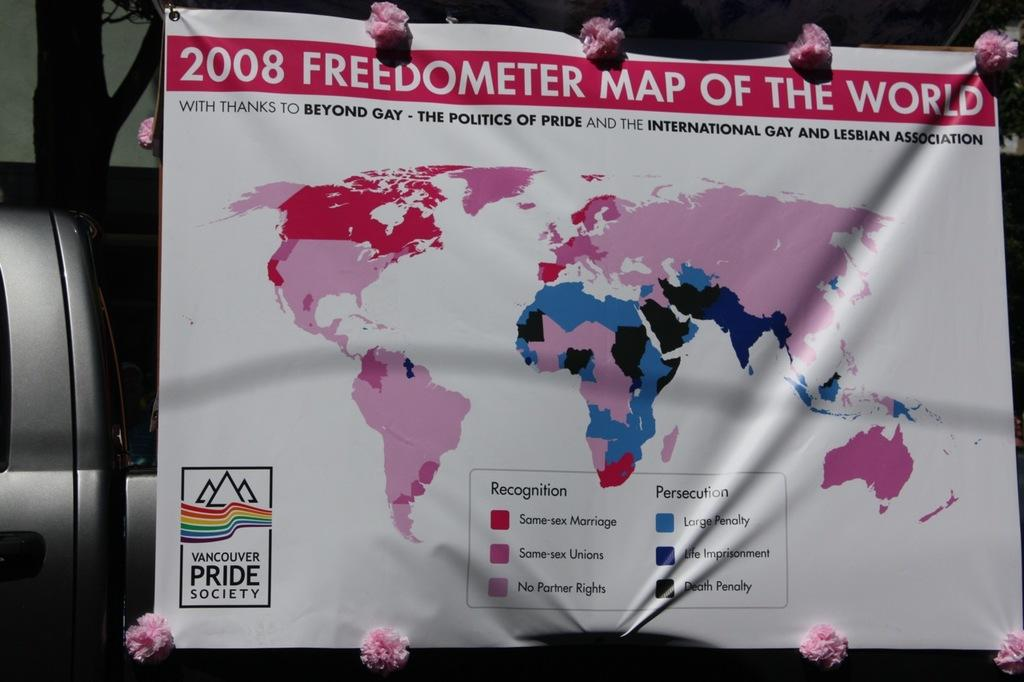<image>
Present a compact description of the photo's key features. The 2008 Freedometer Map of the World is spread out. 